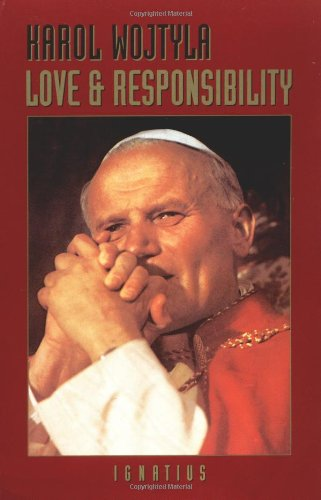What type of book is this? 'Love and Responsibility' is a theological and philosophical book that examines the complexities of human relationships and ethics, based on Christian views. 